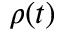Convert formula to latex. <formula><loc_0><loc_0><loc_500><loc_500>\rho ( t )</formula> 